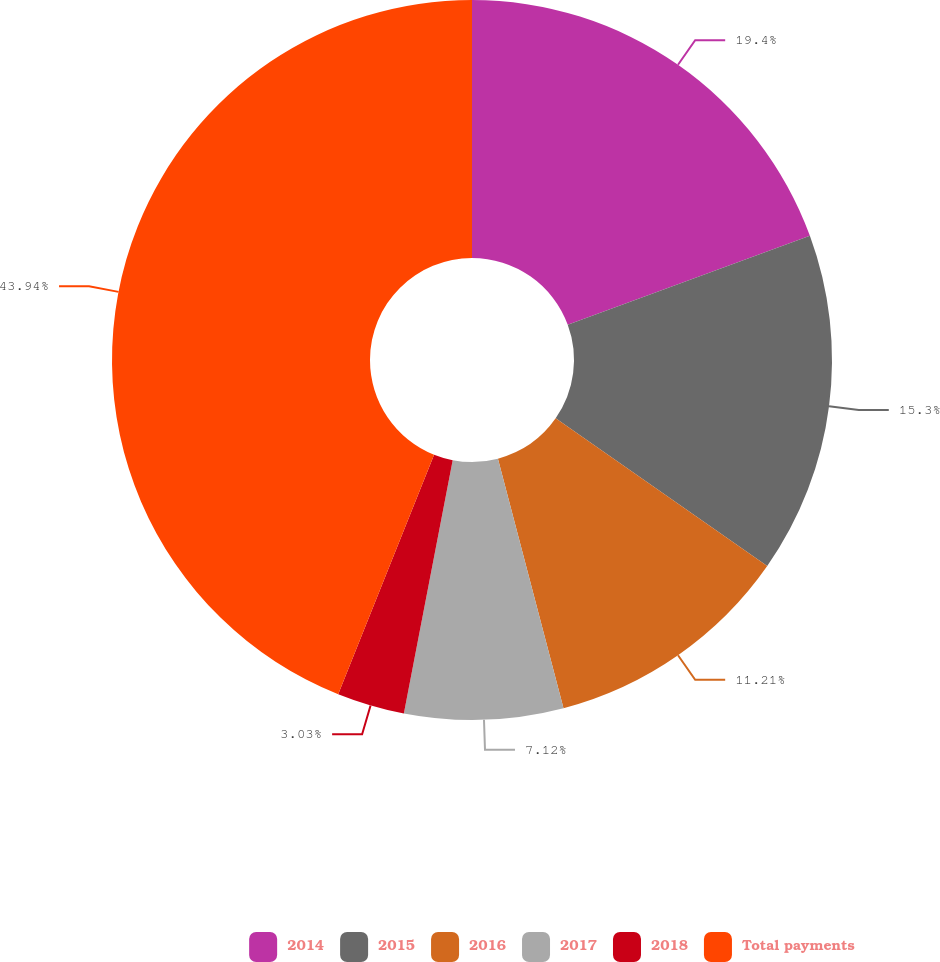<chart> <loc_0><loc_0><loc_500><loc_500><pie_chart><fcel>2014<fcel>2015<fcel>2016<fcel>2017<fcel>2018<fcel>Total payments<nl><fcel>19.39%<fcel>15.3%<fcel>11.21%<fcel>7.12%<fcel>3.03%<fcel>43.93%<nl></chart> 